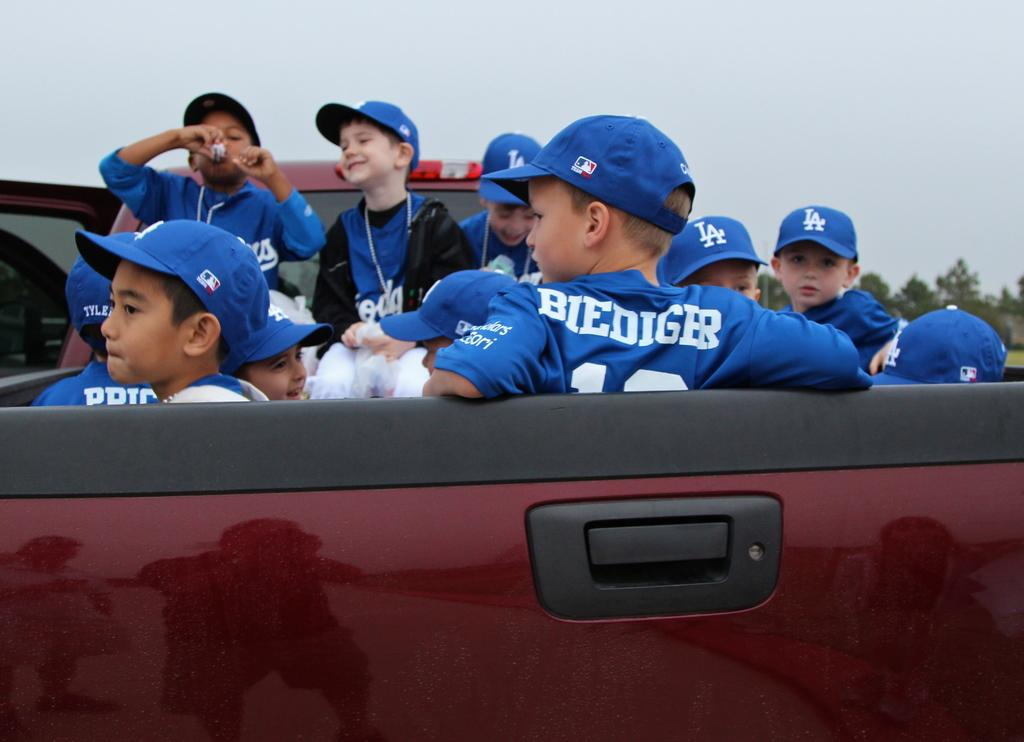<image>
Give a short and clear explanation of the subsequent image. A group of boys in LA caps sit in the back of a truck. 